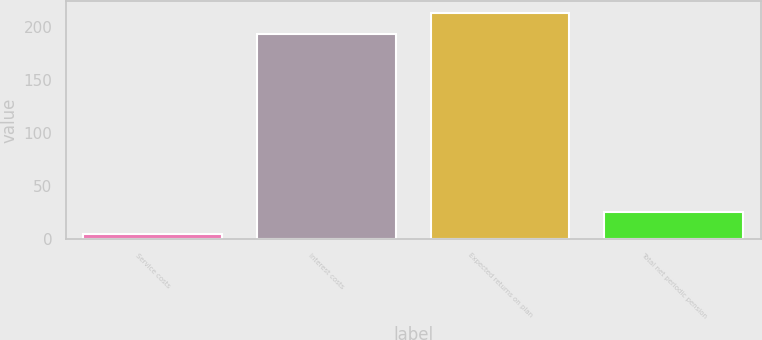Convert chart to OTSL. <chart><loc_0><loc_0><loc_500><loc_500><bar_chart><fcel>Service costs<fcel>Interest costs<fcel>Expected returns on plan<fcel>Total net periodic pension<nl><fcel>5<fcel>193<fcel>213.4<fcel>25.4<nl></chart> 